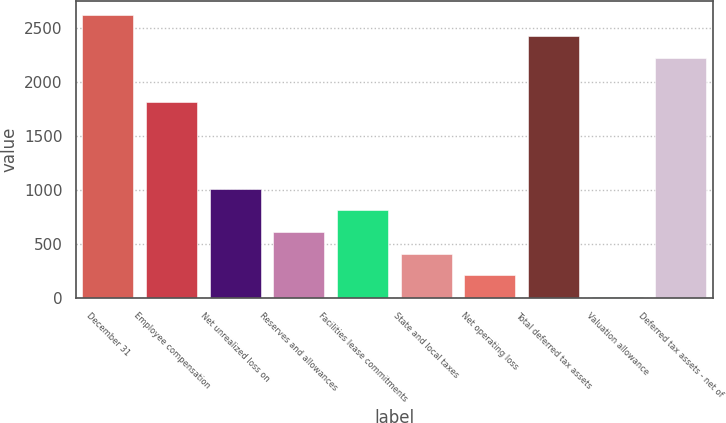Convert chart. <chart><loc_0><loc_0><loc_500><loc_500><bar_chart><fcel>December 31<fcel>Employee compensation<fcel>Net unrealized loss on<fcel>Reserves and allowances<fcel>Facilities lease commitments<fcel>State and local taxes<fcel>Net operating loss<fcel>Total deferred tax assets<fcel>Valuation allowance<fcel>Deferred tax assets - net of<nl><fcel>2619.9<fcel>1814.7<fcel>1009.5<fcel>606.9<fcel>808.2<fcel>405.6<fcel>204.3<fcel>2418.6<fcel>3<fcel>2217.3<nl></chart> 